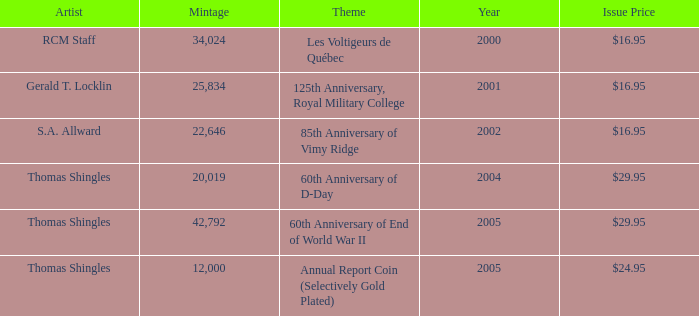What year was S.A. Allward's theme that had an issue price of $16.95 released? 2002.0. 